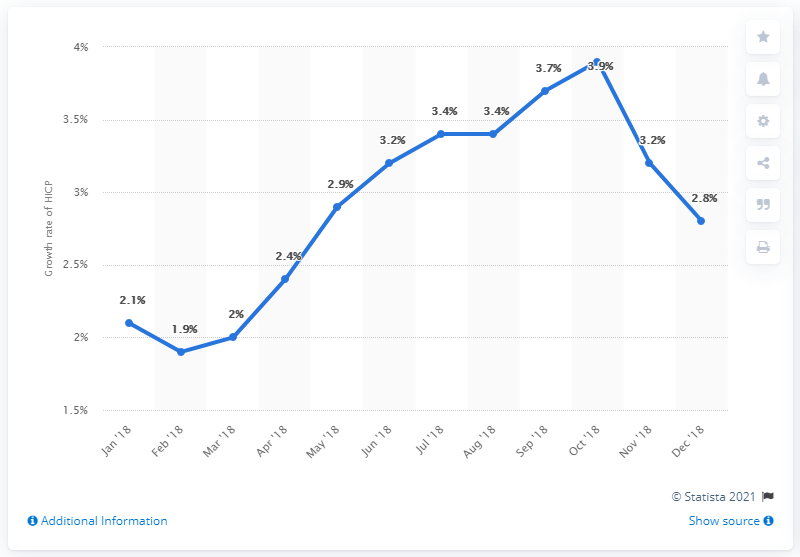Highlight a few significant elements in this photo. For how many times has the rate been over 3%? It has been over 3% 6 times. The peak rate is expected to be reached in October 2018. In December 2018, the inflation rate was 2.8%. 